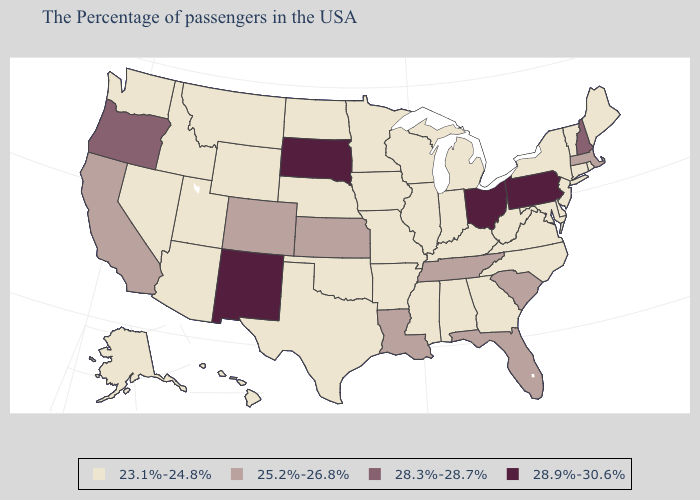What is the value of California?
Be succinct. 25.2%-26.8%. Name the states that have a value in the range 25.2%-26.8%?
Be succinct. Massachusetts, South Carolina, Florida, Tennessee, Louisiana, Kansas, Colorado, California. What is the lowest value in states that border New Jersey?
Keep it brief. 23.1%-24.8%. Name the states that have a value in the range 28.3%-28.7%?
Keep it brief. New Hampshire, Oregon. Does Ohio have the lowest value in the USA?
Write a very short answer. No. What is the lowest value in states that border Arkansas?
Concise answer only. 23.1%-24.8%. Does Utah have the highest value in the West?
Give a very brief answer. No. What is the value of Wyoming?
Quick response, please. 23.1%-24.8%. Among the states that border Arkansas , which have the lowest value?
Short answer required. Mississippi, Missouri, Oklahoma, Texas. Does the first symbol in the legend represent the smallest category?
Concise answer only. Yes. Does Maryland have a higher value than New Jersey?
Be succinct. No. Name the states that have a value in the range 28.9%-30.6%?
Answer briefly. Pennsylvania, Ohio, South Dakota, New Mexico. Among the states that border New Hampshire , which have the lowest value?
Short answer required. Maine, Vermont. What is the value of Missouri?
Concise answer only. 23.1%-24.8%. What is the highest value in the MidWest ?
Quick response, please. 28.9%-30.6%. 